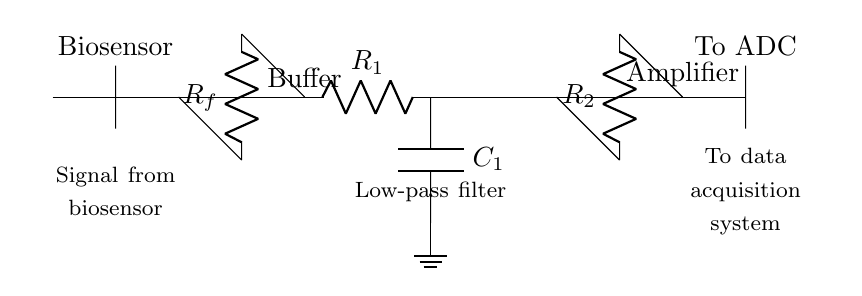What component provides the initial signal conditioning from the biosensor? The circuit starts with a biosensor, which generates an output signal that needs conditioning. This is depicted at the left side of the diagram.
Answer: Biosensor What is the purpose of the buffer amplifier in the circuit? The buffer amplifier is used to isolate the biosensor signal and prevent loading effects, thereby enabling better signal integrity. It is shown connected directly after the biosensor in the diagram.
Answer: Isolation Which component filters out high-frequency noise from the signal? The low-pass filter, consisting of a resistor and capacitor, is designed specifically to attenuate high-frequency noise. This is observed under the buffer amplifier in the circuit.
Answer: Low-pass filter How many operational amplifiers are used in this signal conditioning circuit? The circuit features two operational amplifiers: one for buffering and the other for amplification. Each is clearly labeled in the diagram.
Answer: Two What is the function of the resistor R1 in the low-pass filter? Resistor R1, located in the low-pass filter section, plays a key role in determining the cutoff frequency, along with capacitor C1. The placement of R1 indicates it forms part of this filter configuration.
Answer: Cutoff frequency determination What type of output does this circuit feed into at the end? At the end of the circuit, the output is directed to an analog-to-digital converter (ADC), which digitizes the processed signal for further analysis or storage. This is indicated at the rightmost portion of the diagram.
Answer: To ADC 